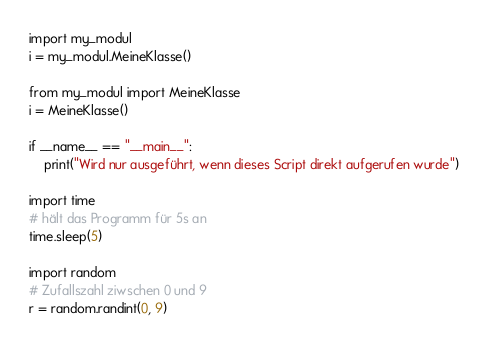<code> <loc_0><loc_0><loc_500><loc_500><_Python_>import my_modul
i = my_modul.MeineKlasse()

from my_modul import MeineKlasse
i = MeineKlasse()

if __name__ == "__main__":
    print("Wird nur ausgeführt, wenn dieses Script direkt aufgerufen wurde")

import time
# hält das Programm für 5s an
time.sleep(5)

import random
# Zufallszahl ziwschen 0 und 9
r = random.randint(0, 9)
</code> 